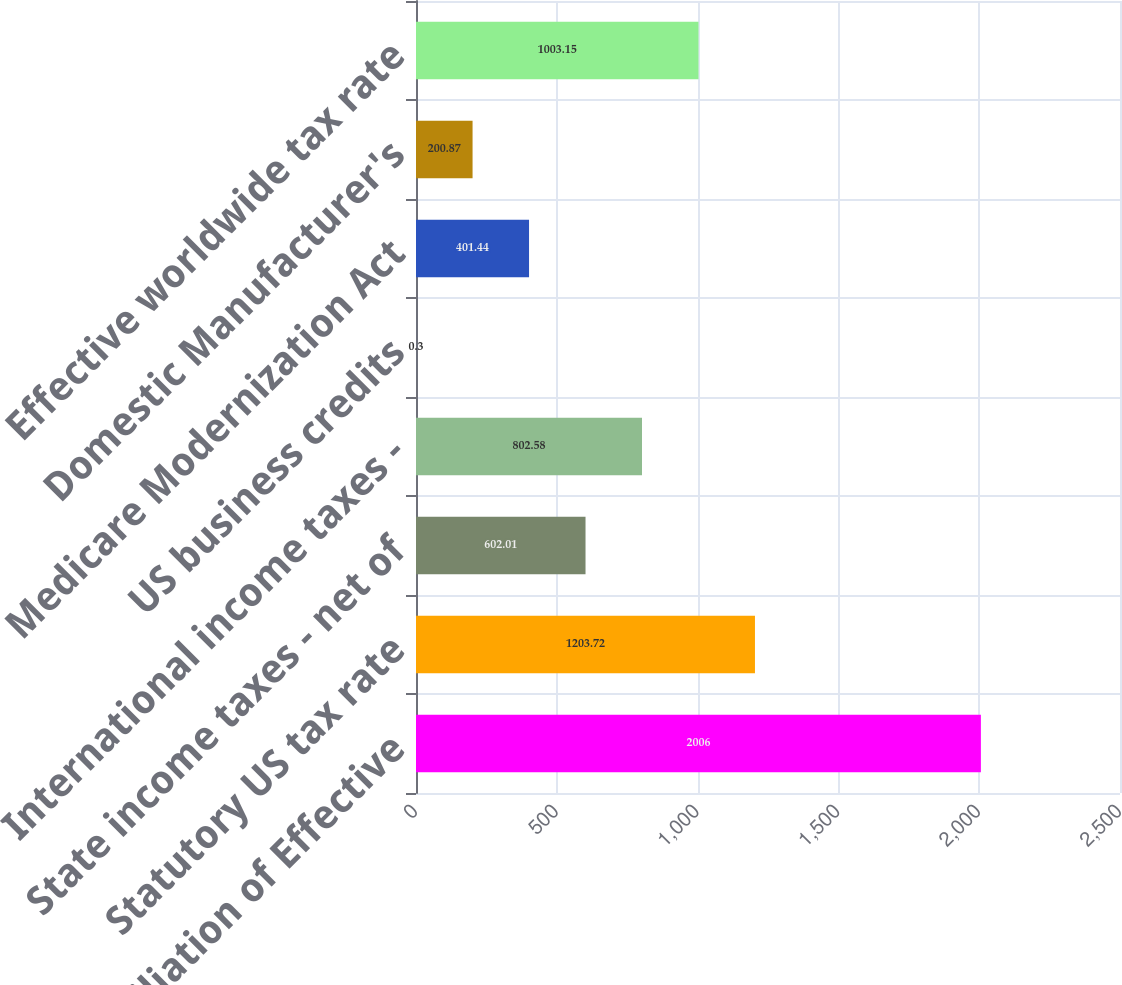<chart> <loc_0><loc_0><loc_500><loc_500><bar_chart><fcel>Reconciliation of Effective<fcel>Statutory US tax rate<fcel>State income taxes - net of<fcel>International income taxes -<fcel>US business credits<fcel>Medicare Modernization Act<fcel>Domestic Manufacturer's<fcel>Effective worldwide tax rate<nl><fcel>2006<fcel>1203.72<fcel>602.01<fcel>802.58<fcel>0.3<fcel>401.44<fcel>200.87<fcel>1003.15<nl></chart> 